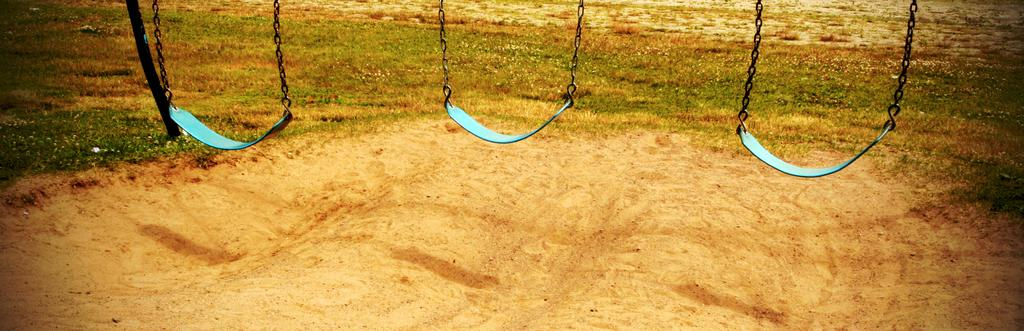What type of playground equipment is present in the image? There are swings with metal chains in the image. What can be seen in the background of the image? There is a pole and grass visible in the background of the image. How many times does the person sneeze in the image? There is no person sneezing in the image; it features swings with metal chains and a background with a pole and grass. 